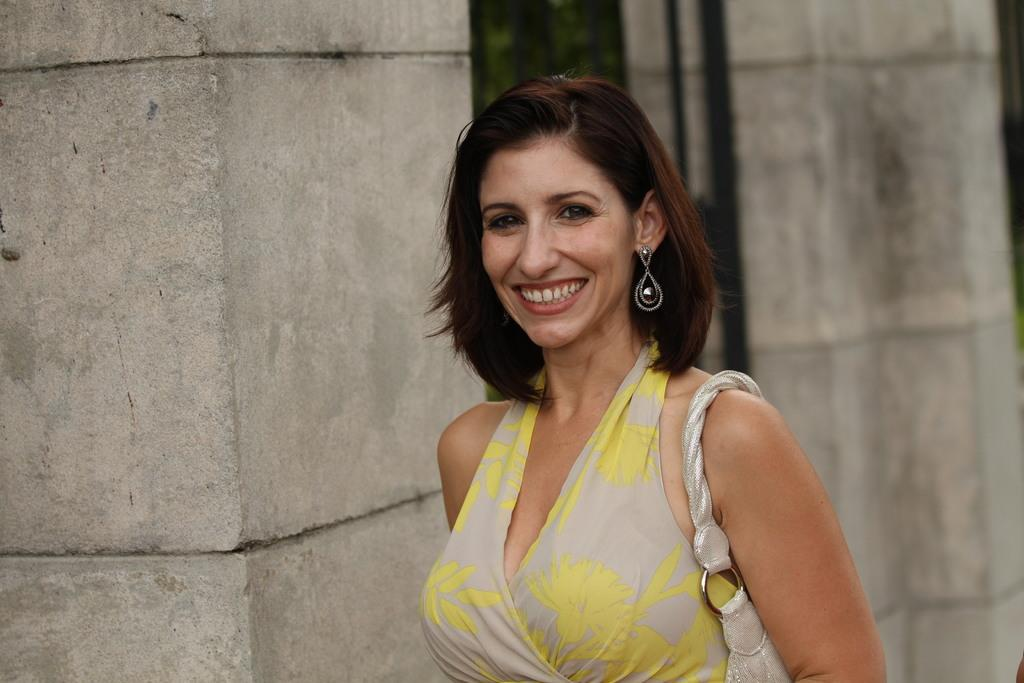Who is the main subject in the image? There is a woman in the image. Where is the woman positioned in the image? The woman is standing in the middle of the image. What expression does the woman have? The woman is smiling. What can be seen behind the woman in the image? There is a wall behind the woman. Is the woman wearing a veil in the image? No, there is no veil present in the image. What type of railway can be seen in the image? There is no railway present in the image; it features a woman standing in front of a wall. 